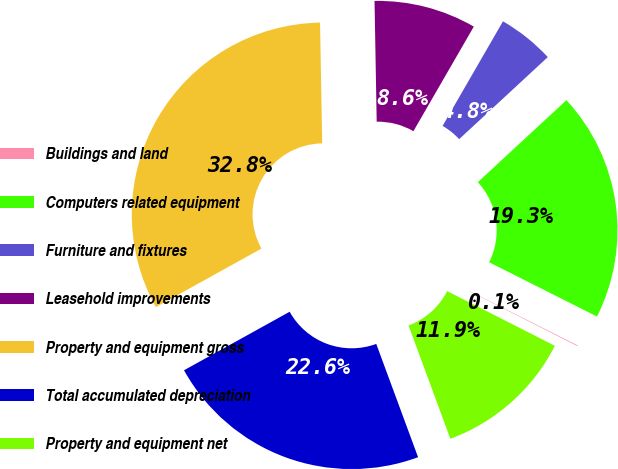Convert chart to OTSL. <chart><loc_0><loc_0><loc_500><loc_500><pie_chart><fcel>Buildings and land<fcel>Computers related equipment<fcel>Furniture and fixtures<fcel>Leasehold improvements<fcel>Property and equipment gross<fcel>Total accumulated depreciation<fcel>Property and equipment net<nl><fcel>0.06%<fcel>19.31%<fcel>4.78%<fcel>8.62%<fcel>32.77%<fcel>22.58%<fcel>11.89%<nl></chart> 